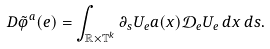<formula> <loc_0><loc_0><loc_500><loc_500>D \tilde { \varphi } ^ { a } ( e ) = \int _ { \mathbb { R } \times \mathbb { T } ^ { k } } \partial _ { s } U _ { e } a ( x ) \mathcal { D } _ { e } U _ { e } \, d x \, d s .</formula> 